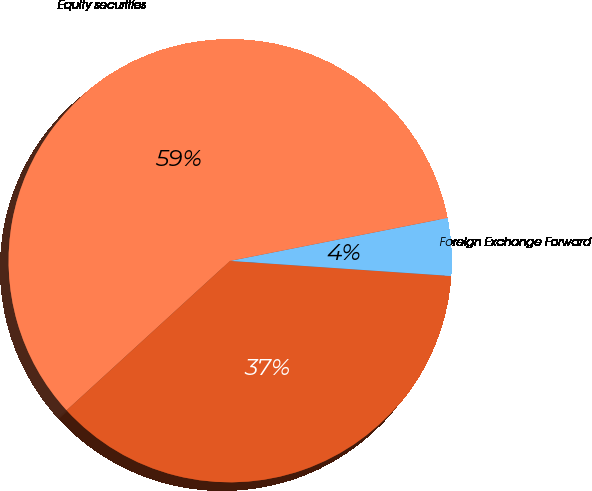<chart> <loc_0><loc_0><loc_500><loc_500><pie_chart><fcel>Commodity Derivatives<fcel>Foreign Exchange Forward<fcel>Equity securities<nl><fcel>37.13%<fcel>4.19%<fcel>58.68%<nl></chart> 